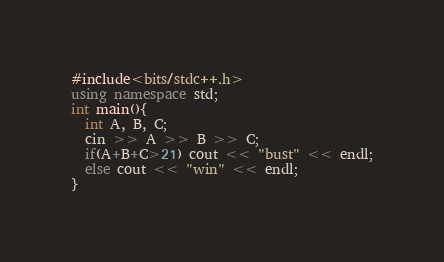<code> <loc_0><loc_0><loc_500><loc_500><_C++_>#include<bits/stdc++.h>
using namespace std;
int main(){
  int A, B, C;
  cin >> A >> B >> C;
  if(A+B+C>21) cout << "bust" << endl;
  else cout << "win" << endl;
}</code> 